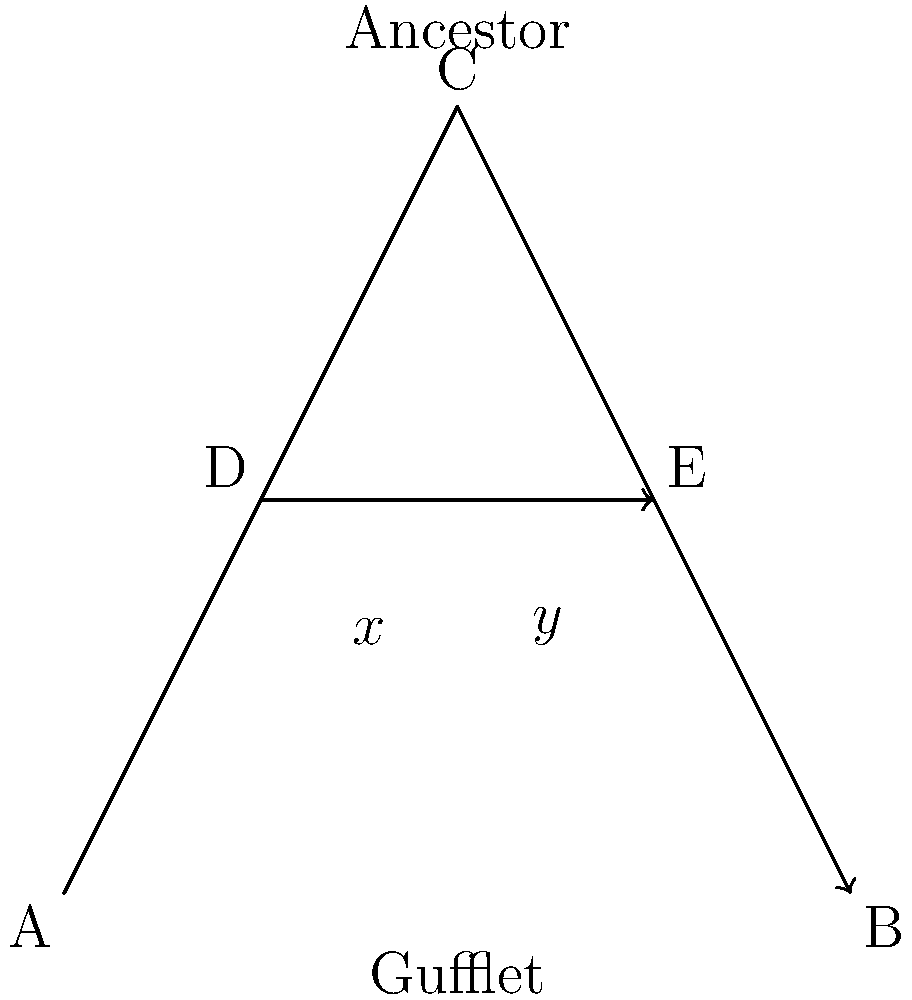In the Gufflet family tree diagram, two branches intersect at point D and E. If the angle formed at D is $x°$ and the angle formed at E is $y°$, what is the value of $x + y$? Let's approach this step-by-step:

1) In the diagram, we see two intersecting line segments: AC and DB.

2) When two lines intersect, they form two pairs of vertical angles. Vertical angles are always congruent (equal).

3) The angles $x°$ and $y°$ are on opposite sides of the point of intersection, making them vertical angles.

4) A fundamental property of intersecting lines is that the sum of the measures of the four angles formed at the intersection point is always 360°.

5) Given that vertical angles are equal, we can represent the four angles as $x°$, $y°$, $x°$, and $y°$.

6) Therefore, we can set up the equation:
   $x + y + x + y = 360°$

7) Simplifying:
   $2x + 2y = 360°$

8) Dividing both sides by 2:
   $x + y = 180°$

Thus, regardless of the individual values of $x$ and $y$, their sum will always be 180°.
Answer: $180°$ 